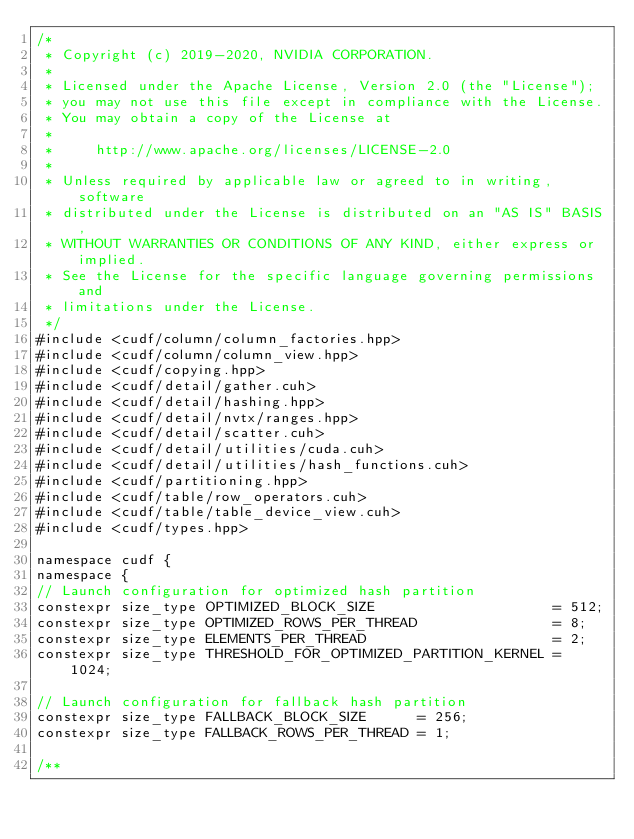Convert code to text. <code><loc_0><loc_0><loc_500><loc_500><_Cuda_>/*
 * Copyright (c) 2019-2020, NVIDIA CORPORATION.
 *
 * Licensed under the Apache License, Version 2.0 (the "License");
 * you may not use this file except in compliance with the License.
 * You may obtain a copy of the License at
 *
 *     http://www.apache.org/licenses/LICENSE-2.0
 *
 * Unless required by applicable law or agreed to in writing, software
 * distributed under the License is distributed on an "AS IS" BASIS,
 * WITHOUT WARRANTIES OR CONDITIONS OF ANY KIND, either express or implied.
 * See the License for the specific language governing permissions and
 * limitations under the License.
 */
#include <cudf/column/column_factories.hpp>
#include <cudf/column/column_view.hpp>
#include <cudf/copying.hpp>
#include <cudf/detail/gather.cuh>
#include <cudf/detail/hashing.hpp>
#include <cudf/detail/nvtx/ranges.hpp>
#include <cudf/detail/scatter.cuh>
#include <cudf/detail/utilities/cuda.cuh>
#include <cudf/detail/utilities/hash_functions.cuh>
#include <cudf/partitioning.hpp>
#include <cudf/table/row_operators.cuh>
#include <cudf/table/table_device_view.cuh>
#include <cudf/types.hpp>

namespace cudf {
namespace {
// Launch configuration for optimized hash partition
constexpr size_type OPTIMIZED_BLOCK_SIZE                     = 512;
constexpr size_type OPTIMIZED_ROWS_PER_THREAD                = 8;
constexpr size_type ELEMENTS_PER_THREAD                      = 2;
constexpr size_type THRESHOLD_FOR_OPTIMIZED_PARTITION_KERNEL = 1024;

// Launch configuration for fallback hash partition
constexpr size_type FALLBACK_BLOCK_SIZE      = 256;
constexpr size_type FALLBACK_ROWS_PER_THREAD = 1;

/**</code> 